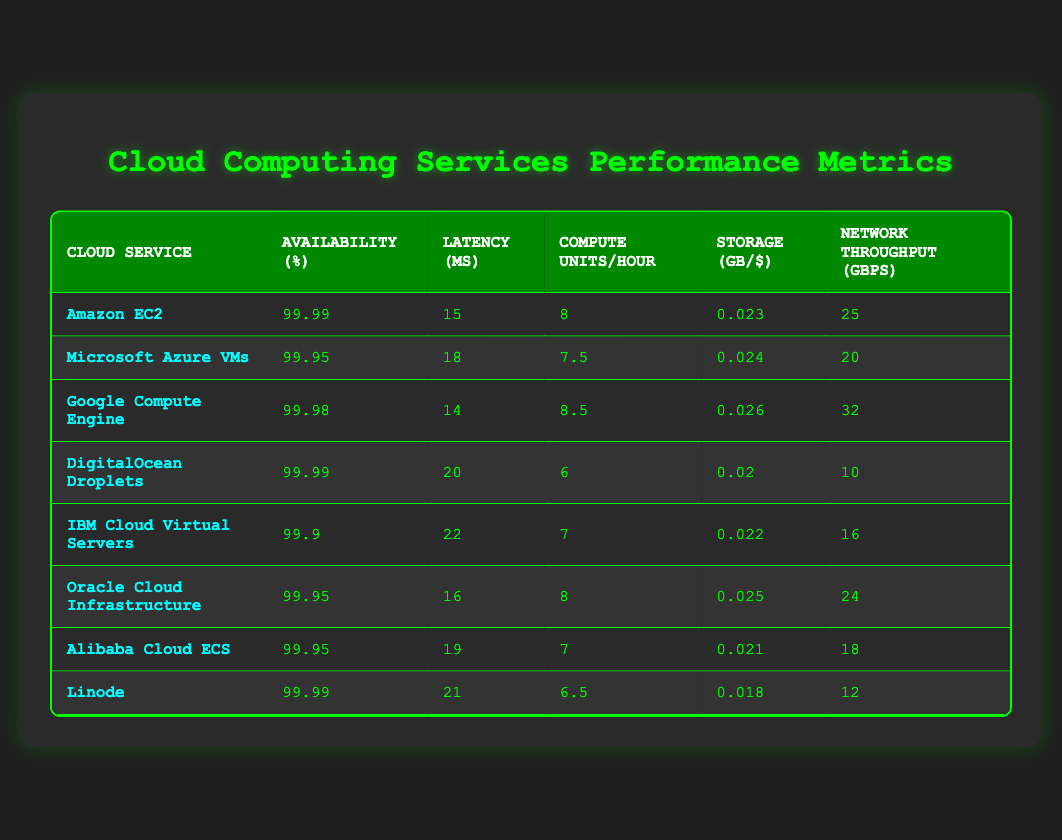What is the availability percentage of Google Compute Engine? The availability percentage can be found in the row corresponding to Google Compute Engine, where it is listed as 99.98%.
Answer: 99.98 Which cloud service has the lowest latency? By looking through the latency column, Google Compute Engine has the lowest latency at 14 ms.
Answer: Google Compute Engine What is the average storage cost per GB across all services? To find the average storage cost, we sum the storage costs (0.023 + 0.024 + 0.026 + 0.02 + 0.022 + 0.025 + 0.021 + 0.018 = 0.189) and divide by the number of services (8) which is 0.189 / 8 = 0.023625.
Answer: 0.023625 Is the network throughput of DigitalOcean Droplets higher than that of IBM Cloud Virtual Servers? From the table, DigitalOcean Droplets has a network throughput of 10 Gbps, while IBM Cloud Virtual Servers has 16 Gbps. Thus, DigitalOcean Droplets does not have higher throughput.
Answer: No Which two cloud services have the same availability percentage? Checking the availability column reveals that Microsoft Azure VMs, Oracle Cloud Infrastructure, and Alibaba Cloud ECS all have an availability percentage of 99.95%.
Answer: Microsoft Azure VMs and Oracle Cloud Infrastructure (or Alibaba Cloud ECS) What is the percentage difference in availability between Amazon EC2 and IBM Cloud Virtual Servers? Amazon EC2 has an availability of 99.99% and IBM Cloud Virtual Servers has 99.9%. The difference is 99.99 - 99.9 = 0.09%.
Answer: 0.09% Which cloud service provides the highest number of compute units per hour? The compute units per hour are compared across services, with Google Compute Engine offering 8.5, which is the highest listed.
Answer: Google Compute Engine If I want to optimize for low latency and high network throughput, which service should I choose? The best choice for low latency and high throughput would be Google Compute Engine with a latency of 14 ms and a network throughput of 32 Gbps, making it the ideal service based on both metrics.
Answer: Google Compute Engine 